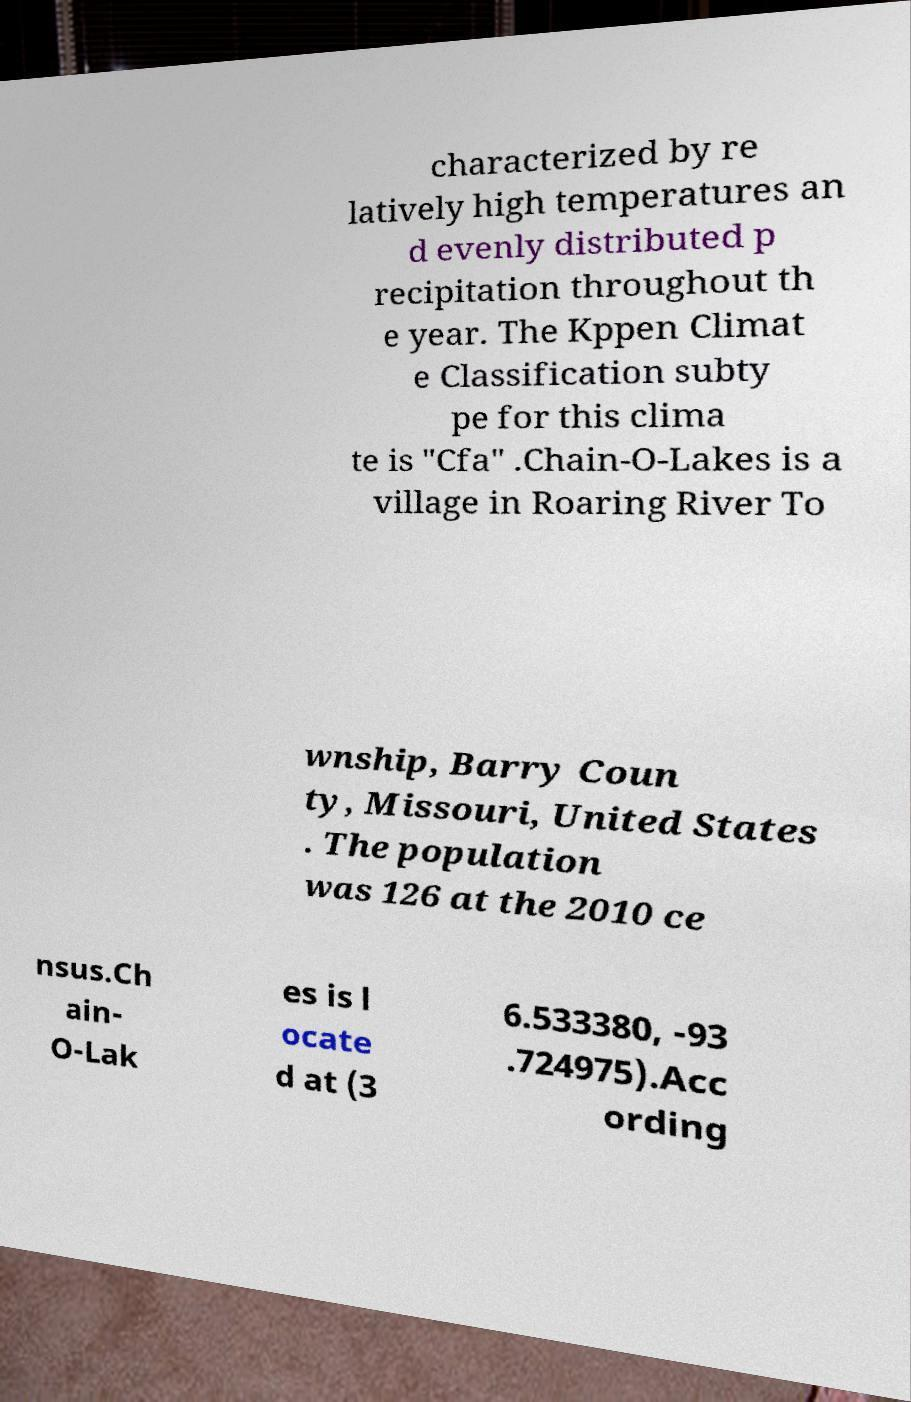For documentation purposes, I need the text within this image transcribed. Could you provide that? characterized by re latively high temperatures an d evenly distributed p recipitation throughout th e year. The Kppen Climat e Classification subty pe for this clima te is "Cfa" .Chain-O-Lakes is a village in Roaring River To wnship, Barry Coun ty, Missouri, United States . The population was 126 at the 2010 ce nsus.Ch ain- O-Lak es is l ocate d at (3 6.533380, -93 .724975).Acc ording 